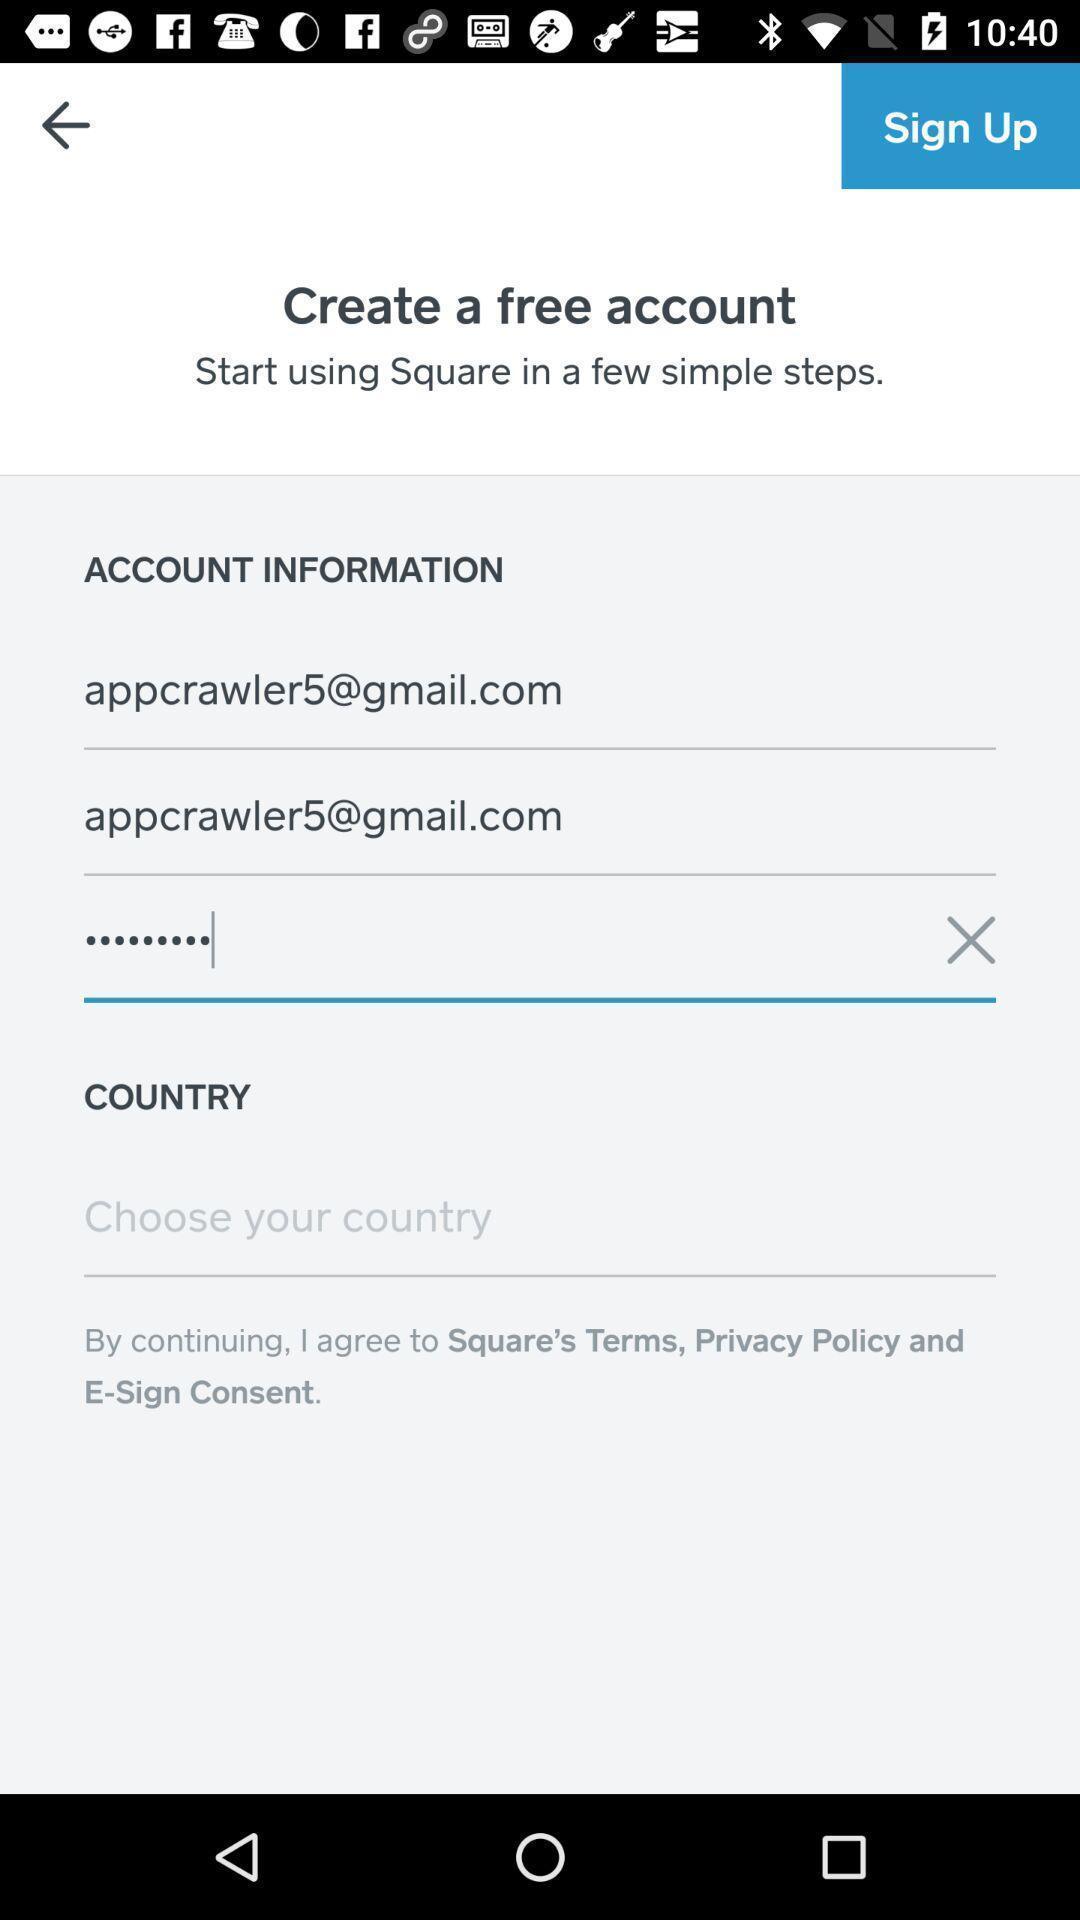What can you discern from this picture? Page displaying the account information. 